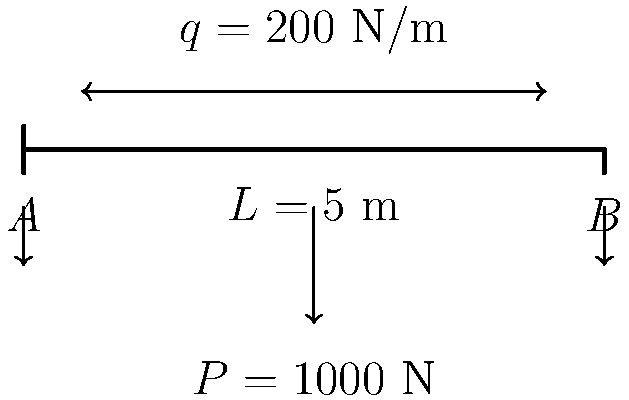A simply supported beam of length $L = 5$ m is subjected to a uniform distributed load $q = 200$ N/m along its entire length and a point load $P = 1000$ N at its midpoint. Using the principle of superposition, determine the maximum bending moment in the beam. How does this loading condition relate to the social implications of penicillin production? To solve this problem, we'll use the principle of superposition and follow these steps:

1. Calculate the maximum bending moment due to the uniformly distributed load:
   $M_{max,q} = \frac{qL^2}{8} = \frac{200 \cdot 5^2}{8} = 625$ N·m

2. Calculate the maximum bending moment due to the point load:
   $M_{max,P} = \frac{PL}{4} = \frac{1000 \cdot 5}{4} = 1250$ N·m

3. Sum the two maximum bending moments:
   $M_{max,total} = M_{max,q} + M_{max,P} = 625 + 1250 = 1875$ N·m

4. Relate to penicillin production:
   The analysis of stress distribution in beams is crucial for designing pharmaceutical manufacturing facilities, including those for penicillin production. Proper structural design ensures safety and efficiency in the production process, which has significant social implications, such as increased accessibility to life-saving antibiotics.
Answer: $M_{max,total} = 1875$ N·m; Ensures safe, efficient penicillin production facilities. 